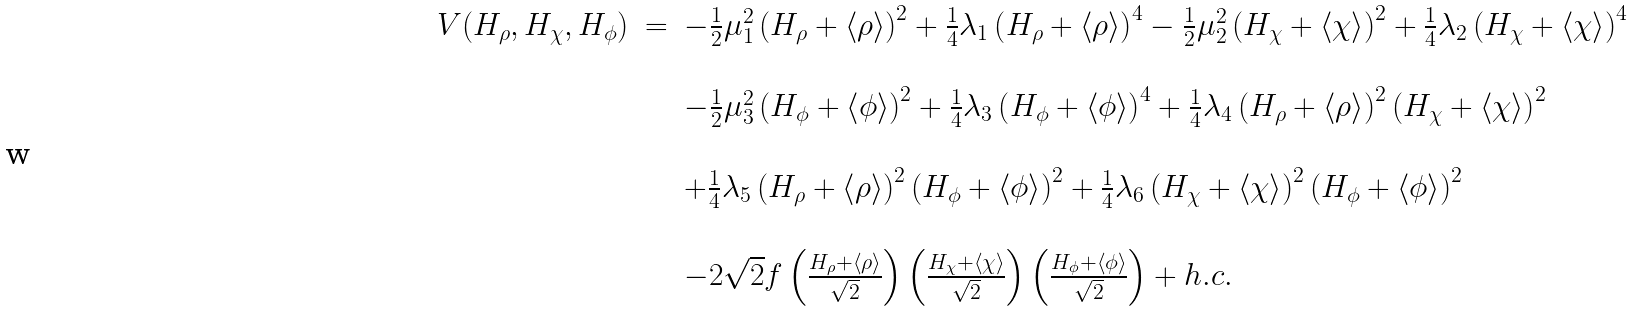Convert formula to latex. <formula><loc_0><loc_0><loc_500><loc_500>\begin{array} { c c l } V ( H _ { \rho } , H _ { \chi } , H _ { \phi } ) & = & - \frac { 1 } { 2 } \mu _ { 1 } ^ { 2 } \left ( H _ { \rho } + \left \langle \rho \right \rangle \right ) ^ { 2 } + \frac { 1 } { 4 } \lambda _ { 1 } \left ( H _ { \rho } + \left \langle \rho \right \rangle \right ) ^ { 4 } - \frac { 1 } { 2 } \mu _ { 2 } ^ { 2 } \left ( H _ { \chi } + \left \langle \chi \right \rangle \right ) ^ { 2 } + \frac { 1 } { 4 } \lambda _ { 2 } \left ( H _ { \chi } + \left \langle \chi \right \rangle \right ) ^ { 4 } \\ \\ & & - \frac { 1 } { 2 } \mu _ { 3 } ^ { 2 } \left ( H _ { \phi } + \left \langle \phi \right \rangle \right ) ^ { 2 } + \frac { 1 } { 4 } \lambda _ { 3 } \left ( H _ { \phi } + \left \langle \phi \right \rangle \right ) ^ { 4 } + \frac { 1 } { 4 } \lambda _ { 4 } \left ( H _ { \rho } + \left \langle \rho \right \rangle \right ) ^ { 2 } \left ( H _ { \chi } + \left \langle \chi \right \rangle \right ) ^ { 2 } \\ \\ & & + \frac { 1 } { 4 } \lambda _ { 5 } \left ( H _ { \rho } + \left \langle \rho \right \rangle \right ) ^ { 2 } \left ( H _ { \phi } + \left \langle \phi \right \rangle \right ) ^ { 2 } + \frac { 1 } { 4 } \lambda _ { 6 } \left ( H _ { \chi } + \left \langle \chi \right \rangle \right ) ^ { 2 } \left ( H _ { \phi } + \left \langle \phi \right \rangle \right ) ^ { 2 } \\ \\ & & - 2 \sqrt { 2 } f \left ( \frac { H _ { \rho } + \left \langle \rho \right \rangle } { \sqrt { 2 } } \right ) \left ( \frac { H _ { \chi } + \left \langle \chi \right \rangle } { \sqrt { 2 } } \right ) \left ( \frac { H _ { \phi } + \left \langle \phi \right \rangle } { \sqrt { 2 } } \right ) + h . c . \end{array}</formula> 